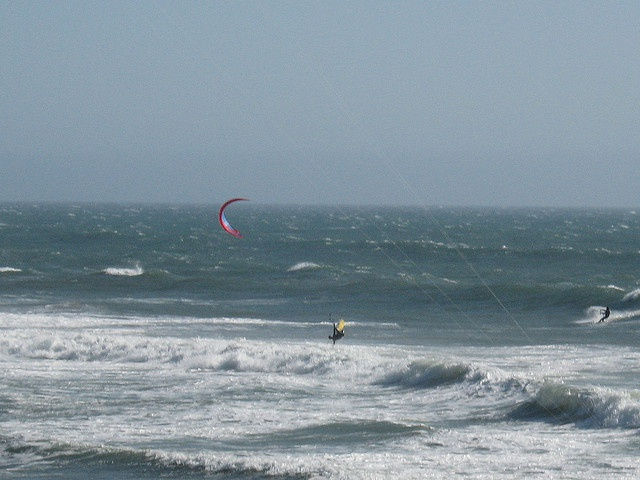Describe the objects in this image and their specific colors. I can see kite in darkgray, brown, gray, maroon, and purple tones, people in darkgray, black, gray, and darkblue tones, surfboard in darkgray, tan, and gray tones, and people in darkgray, black, gray, and purple tones in this image. 